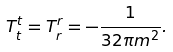<formula> <loc_0><loc_0><loc_500><loc_500>T _ { t } ^ { t } = T _ { r } ^ { r } = - \frac { 1 } { 3 2 \pi m ^ { 2 } } .</formula> 